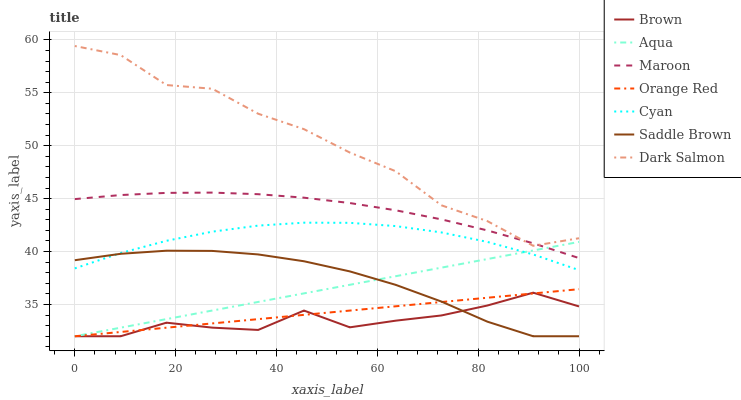Does Brown have the minimum area under the curve?
Answer yes or no. Yes. Does Dark Salmon have the maximum area under the curve?
Answer yes or no. Yes. Does Aqua have the minimum area under the curve?
Answer yes or no. No. Does Aqua have the maximum area under the curve?
Answer yes or no. No. Is Aqua the smoothest?
Answer yes or no. Yes. Is Dark Salmon the roughest?
Answer yes or no. Yes. Is Dark Salmon the smoothest?
Answer yes or no. No. Is Aqua the roughest?
Answer yes or no. No. Does Brown have the lowest value?
Answer yes or no. Yes. Does Dark Salmon have the lowest value?
Answer yes or no. No. Does Dark Salmon have the highest value?
Answer yes or no. Yes. Does Aqua have the highest value?
Answer yes or no. No. Is Brown less than Maroon?
Answer yes or no. Yes. Is Maroon greater than Brown?
Answer yes or no. Yes. Does Cyan intersect Aqua?
Answer yes or no. Yes. Is Cyan less than Aqua?
Answer yes or no. No. Is Cyan greater than Aqua?
Answer yes or no. No. Does Brown intersect Maroon?
Answer yes or no. No. 